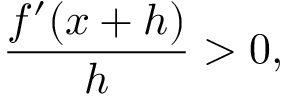<formula> <loc_0><loc_0><loc_500><loc_500>{ \frac { f ^ { \prime } ( x + h ) } { h } } > 0 ,</formula> 